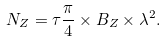<formula> <loc_0><loc_0><loc_500><loc_500>N _ { Z } = \tau \frac { \pi } { 4 } \times B _ { Z } \times { \lambda } ^ { 2 } .</formula> 